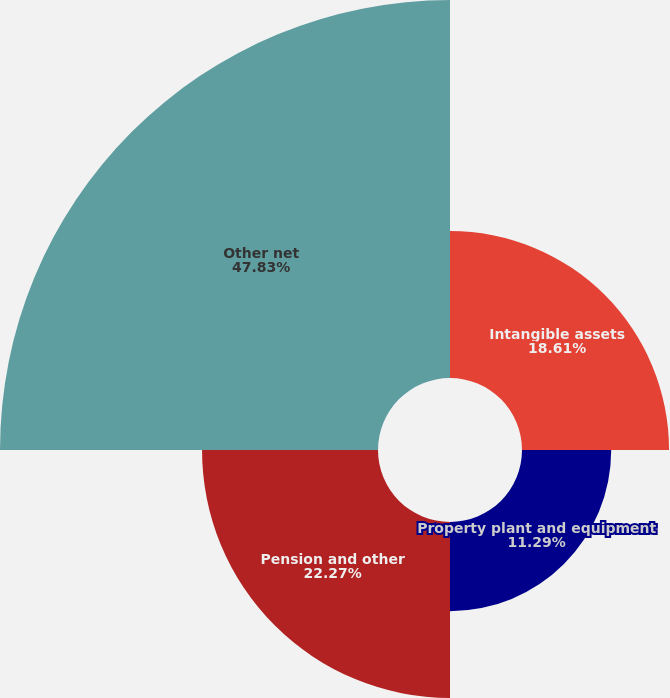Convert chart to OTSL. <chart><loc_0><loc_0><loc_500><loc_500><pie_chart><fcel>Intangible assets<fcel>Property plant and equipment<fcel>Pension and other<fcel>Other net<nl><fcel>18.61%<fcel>11.29%<fcel>22.27%<fcel>47.84%<nl></chart> 